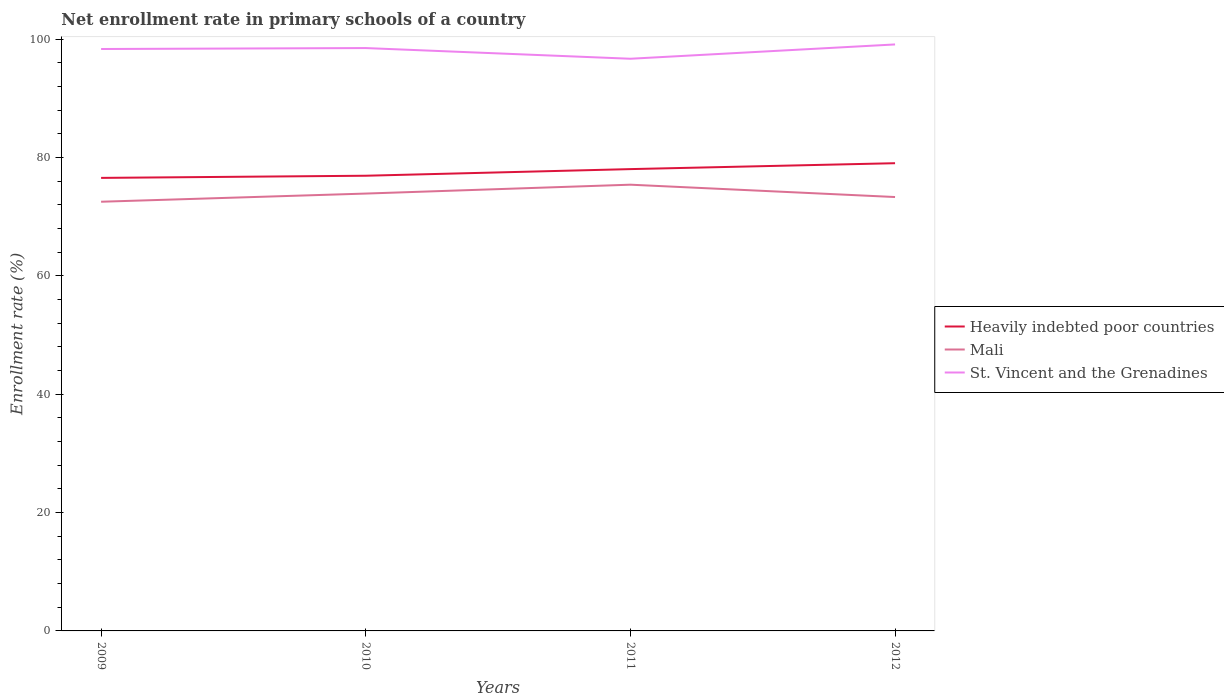How many different coloured lines are there?
Ensure brevity in your answer.  3. Does the line corresponding to St. Vincent and the Grenadines intersect with the line corresponding to Heavily indebted poor countries?
Make the answer very short. No. Is the number of lines equal to the number of legend labels?
Provide a succinct answer. Yes. Across all years, what is the maximum enrollment rate in primary schools in Mali?
Your answer should be compact. 72.53. What is the total enrollment rate in primary schools in St. Vincent and the Grenadines in the graph?
Offer a very short reply. -0.61. What is the difference between the highest and the second highest enrollment rate in primary schools in Heavily indebted poor countries?
Offer a terse response. 2.48. Is the enrollment rate in primary schools in Mali strictly greater than the enrollment rate in primary schools in St. Vincent and the Grenadines over the years?
Offer a terse response. Yes. Where does the legend appear in the graph?
Make the answer very short. Center right. How are the legend labels stacked?
Your answer should be compact. Vertical. What is the title of the graph?
Your response must be concise. Net enrollment rate in primary schools of a country. What is the label or title of the Y-axis?
Ensure brevity in your answer.  Enrollment rate (%). What is the Enrollment rate (%) of Heavily indebted poor countries in 2009?
Offer a very short reply. 76.56. What is the Enrollment rate (%) in Mali in 2009?
Keep it short and to the point. 72.53. What is the Enrollment rate (%) in St. Vincent and the Grenadines in 2009?
Your response must be concise. 98.34. What is the Enrollment rate (%) in Heavily indebted poor countries in 2010?
Offer a very short reply. 76.92. What is the Enrollment rate (%) of Mali in 2010?
Offer a very short reply. 73.91. What is the Enrollment rate (%) of St. Vincent and the Grenadines in 2010?
Make the answer very short. 98.5. What is the Enrollment rate (%) in Heavily indebted poor countries in 2011?
Offer a very short reply. 78.05. What is the Enrollment rate (%) in Mali in 2011?
Your answer should be very brief. 75.41. What is the Enrollment rate (%) in St. Vincent and the Grenadines in 2011?
Your answer should be very brief. 96.7. What is the Enrollment rate (%) of Heavily indebted poor countries in 2012?
Provide a succinct answer. 79.04. What is the Enrollment rate (%) in Mali in 2012?
Offer a terse response. 73.33. What is the Enrollment rate (%) of St. Vincent and the Grenadines in 2012?
Your answer should be very brief. 99.11. Across all years, what is the maximum Enrollment rate (%) of Heavily indebted poor countries?
Your answer should be very brief. 79.04. Across all years, what is the maximum Enrollment rate (%) of Mali?
Your answer should be compact. 75.41. Across all years, what is the maximum Enrollment rate (%) of St. Vincent and the Grenadines?
Give a very brief answer. 99.11. Across all years, what is the minimum Enrollment rate (%) in Heavily indebted poor countries?
Keep it short and to the point. 76.56. Across all years, what is the minimum Enrollment rate (%) in Mali?
Give a very brief answer. 72.53. Across all years, what is the minimum Enrollment rate (%) in St. Vincent and the Grenadines?
Your answer should be very brief. 96.7. What is the total Enrollment rate (%) in Heavily indebted poor countries in the graph?
Ensure brevity in your answer.  310.58. What is the total Enrollment rate (%) of Mali in the graph?
Make the answer very short. 295.18. What is the total Enrollment rate (%) of St. Vincent and the Grenadines in the graph?
Make the answer very short. 392.66. What is the difference between the Enrollment rate (%) of Heavily indebted poor countries in 2009 and that in 2010?
Give a very brief answer. -0.36. What is the difference between the Enrollment rate (%) of Mali in 2009 and that in 2010?
Provide a succinct answer. -1.38. What is the difference between the Enrollment rate (%) in St. Vincent and the Grenadines in 2009 and that in 2010?
Your answer should be compact. -0.16. What is the difference between the Enrollment rate (%) in Heavily indebted poor countries in 2009 and that in 2011?
Your response must be concise. -1.48. What is the difference between the Enrollment rate (%) of Mali in 2009 and that in 2011?
Provide a succinct answer. -2.88. What is the difference between the Enrollment rate (%) of St. Vincent and the Grenadines in 2009 and that in 2011?
Make the answer very short. 1.65. What is the difference between the Enrollment rate (%) in Heavily indebted poor countries in 2009 and that in 2012?
Keep it short and to the point. -2.48. What is the difference between the Enrollment rate (%) in Mali in 2009 and that in 2012?
Offer a terse response. -0.8. What is the difference between the Enrollment rate (%) of St. Vincent and the Grenadines in 2009 and that in 2012?
Ensure brevity in your answer.  -0.77. What is the difference between the Enrollment rate (%) in Heavily indebted poor countries in 2010 and that in 2011?
Provide a short and direct response. -1.12. What is the difference between the Enrollment rate (%) in Mali in 2010 and that in 2011?
Provide a succinct answer. -1.5. What is the difference between the Enrollment rate (%) in St. Vincent and the Grenadines in 2010 and that in 2011?
Your response must be concise. 1.81. What is the difference between the Enrollment rate (%) in Heavily indebted poor countries in 2010 and that in 2012?
Your answer should be very brief. -2.12. What is the difference between the Enrollment rate (%) in Mali in 2010 and that in 2012?
Make the answer very short. 0.59. What is the difference between the Enrollment rate (%) of St. Vincent and the Grenadines in 2010 and that in 2012?
Offer a very short reply. -0.61. What is the difference between the Enrollment rate (%) in Heavily indebted poor countries in 2011 and that in 2012?
Make the answer very short. -1. What is the difference between the Enrollment rate (%) of Mali in 2011 and that in 2012?
Your answer should be compact. 2.09. What is the difference between the Enrollment rate (%) in St. Vincent and the Grenadines in 2011 and that in 2012?
Your answer should be very brief. -2.42. What is the difference between the Enrollment rate (%) of Heavily indebted poor countries in 2009 and the Enrollment rate (%) of Mali in 2010?
Provide a succinct answer. 2.65. What is the difference between the Enrollment rate (%) in Heavily indebted poor countries in 2009 and the Enrollment rate (%) in St. Vincent and the Grenadines in 2010?
Keep it short and to the point. -21.94. What is the difference between the Enrollment rate (%) of Mali in 2009 and the Enrollment rate (%) of St. Vincent and the Grenadines in 2010?
Keep it short and to the point. -25.97. What is the difference between the Enrollment rate (%) of Heavily indebted poor countries in 2009 and the Enrollment rate (%) of Mali in 2011?
Your answer should be very brief. 1.15. What is the difference between the Enrollment rate (%) of Heavily indebted poor countries in 2009 and the Enrollment rate (%) of St. Vincent and the Grenadines in 2011?
Your answer should be compact. -20.13. What is the difference between the Enrollment rate (%) of Mali in 2009 and the Enrollment rate (%) of St. Vincent and the Grenadines in 2011?
Your answer should be very brief. -24.17. What is the difference between the Enrollment rate (%) in Heavily indebted poor countries in 2009 and the Enrollment rate (%) in Mali in 2012?
Keep it short and to the point. 3.24. What is the difference between the Enrollment rate (%) in Heavily indebted poor countries in 2009 and the Enrollment rate (%) in St. Vincent and the Grenadines in 2012?
Offer a terse response. -22.55. What is the difference between the Enrollment rate (%) in Mali in 2009 and the Enrollment rate (%) in St. Vincent and the Grenadines in 2012?
Provide a succinct answer. -26.58. What is the difference between the Enrollment rate (%) in Heavily indebted poor countries in 2010 and the Enrollment rate (%) in Mali in 2011?
Your answer should be compact. 1.51. What is the difference between the Enrollment rate (%) of Heavily indebted poor countries in 2010 and the Enrollment rate (%) of St. Vincent and the Grenadines in 2011?
Offer a terse response. -19.77. What is the difference between the Enrollment rate (%) of Mali in 2010 and the Enrollment rate (%) of St. Vincent and the Grenadines in 2011?
Offer a terse response. -22.78. What is the difference between the Enrollment rate (%) of Heavily indebted poor countries in 2010 and the Enrollment rate (%) of Mali in 2012?
Keep it short and to the point. 3.6. What is the difference between the Enrollment rate (%) of Heavily indebted poor countries in 2010 and the Enrollment rate (%) of St. Vincent and the Grenadines in 2012?
Ensure brevity in your answer.  -22.19. What is the difference between the Enrollment rate (%) of Mali in 2010 and the Enrollment rate (%) of St. Vincent and the Grenadines in 2012?
Give a very brief answer. -25.2. What is the difference between the Enrollment rate (%) of Heavily indebted poor countries in 2011 and the Enrollment rate (%) of Mali in 2012?
Your answer should be compact. 4.72. What is the difference between the Enrollment rate (%) in Heavily indebted poor countries in 2011 and the Enrollment rate (%) in St. Vincent and the Grenadines in 2012?
Offer a terse response. -21.07. What is the difference between the Enrollment rate (%) of Mali in 2011 and the Enrollment rate (%) of St. Vincent and the Grenadines in 2012?
Your answer should be very brief. -23.7. What is the average Enrollment rate (%) of Heavily indebted poor countries per year?
Give a very brief answer. 77.64. What is the average Enrollment rate (%) of Mali per year?
Offer a terse response. 73.8. What is the average Enrollment rate (%) of St. Vincent and the Grenadines per year?
Provide a succinct answer. 98.16. In the year 2009, what is the difference between the Enrollment rate (%) of Heavily indebted poor countries and Enrollment rate (%) of Mali?
Offer a very short reply. 4.03. In the year 2009, what is the difference between the Enrollment rate (%) of Heavily indebted poor countries and Enrollment rate (%) of St. Vincent and the Grenadines?
Provide a succinct answer. -21.78. In the year 2009, what is the difference between the Enrollment rate (%) of Mali and Enrollment rate (%) of St. Vincent and the Grenadines?
Your answer should be very brief. -25.81. In the year 2010, what is the difference between the Enrollment rate (%) in Heavily indebted poor countries and Enrollment rate (%) in Mali?
Keep it short and to the point. 3.01. In the year 2010, what is the difference between the Enrollment rate (%) in Heavily indebted poor countries and Enrollment rate (%) in St. Vincent and the Grenadines?
Your response must be concise. -21.58. In the year 2010, what is the difference between the Enrollment rate (%) of Mali and Enrollment rate (%) of St. Vincent and the Grenadines?
Your answer should be very brief. -24.59. In the year 2011, what is the difference between the Enrollment rate (%) of Heavily indebted poor countries and Enrollment rate (%) of Mali?
Ensure brevity in your answer.  2.63. In the year 2011, what is the difference between the Enrollment rate (%) of Heavily indebted poor countries and Enrollment rate (%) of St. Vincent and the Grenadines?
Give a very brief answer. -18.65. In the year 2011, what is the difference between the Enrollment rate (%) of Mali and Enrollment rate (%) of St. Vincent and the Grenadines?
Your answer should be compact. -21.28. In the year 2012, what is the difference between the Enrollment rate (%) in Heavily indebted poor countries and Enrollment rate (%) in Mali?
Offer a terse response. 5.72. In the year 2012, what is the difference between the Enrollment rate (%) of Heavily indebted poor countries and Enrollment rate (%) of St. Vincent and the Grenadines?
Give a very brief answer. -20.07. In the year 2012, what is the difference between the Enrollment rate (%) of Mali and Enrollment rate (%) of St. Vincent and the Grenadines?
Keep it short and to the point. -25.79. What is the ratio of the Enrollment rate (%) of Heavily indebted poor countries in 2009 to that in 2010?
Give a very brief answer. 1. What is the ratio of the Enrollment rate (%) of Mali in 2009 to that in 2010?
Keep it short and to the point. 0.98. What is the ratio of the Enrollment rate (%) in Mali in 2009 to that in 2011?
Provide a succinct answer. 0.96. What is the ratio of the Enrollment rate (%) of Heavily indebted poor countries in 2009 to that in 2012?
Make the answer very short. 0.97. What is the ratio of the Enrollment rate (%) of Heavily indebted poor countries in 2010 to that in 2011?
Offer a terse response. 0.99. What is the ratio of the Enrollment rate (%) in Mali in 2010 to that in 2011?
Keep it short and to the point. 0.98. What is the ratio of the Enrollment rate (%) of St. Vincent and the Grenadines in 2010 to that in 2011?
Offer a terse response. 1.02. What is the ratio of the Enrollment rate (%) in Heavily indebted poor countries in 2010 to that in 2012?
Make the answer very short. 0.97. What is the ratio of the Enrollment rate (%) in Mali in 2010 to that in 2012?
Your answer should be very brief. 1.01. What is the ratio of the Enrollment rate (%) in Heavily indebted poor countries in 2011 to that in 2012?
Provide a short and direct response. 0.99. What is the ratio of the Enrollment rate (%) in Mali in 2011 to that in 2012?
Your response must be concise. 1.03. What is the ratio of the Enrollment rate (%) in St. Vincent and the Grenadines in 2011 to that in 2012?
Provide a short and direct response. 0.98. What is the difference between the highest and the second highest Enrollment rate (%) of Heavily indebted poor countries?
Your response must be concise. 1. What is the difference between the highest and the second highest Enrollment rate (%) of Mali?
Your answer should be compact. 1.5. What is the difference between the highest and the second highest Enrollment rate (%) in St. Vincent and the Grenadines?
Your answer should be compact. 0.61. What is the difference between the highest and the lowest Enrollment rate (%) in Heavily indebted poor countries?
Make the answer very short. 2.48. What is the difference between the highest and the lowest Enrollment rate (%) of Mali?
Your answer should be compact. 2.88. What is the difference between the highest and the lowest Enrollment rate (%) of St. Vincent and the Grenadines?
Provide a short and direct response. 2.42. 